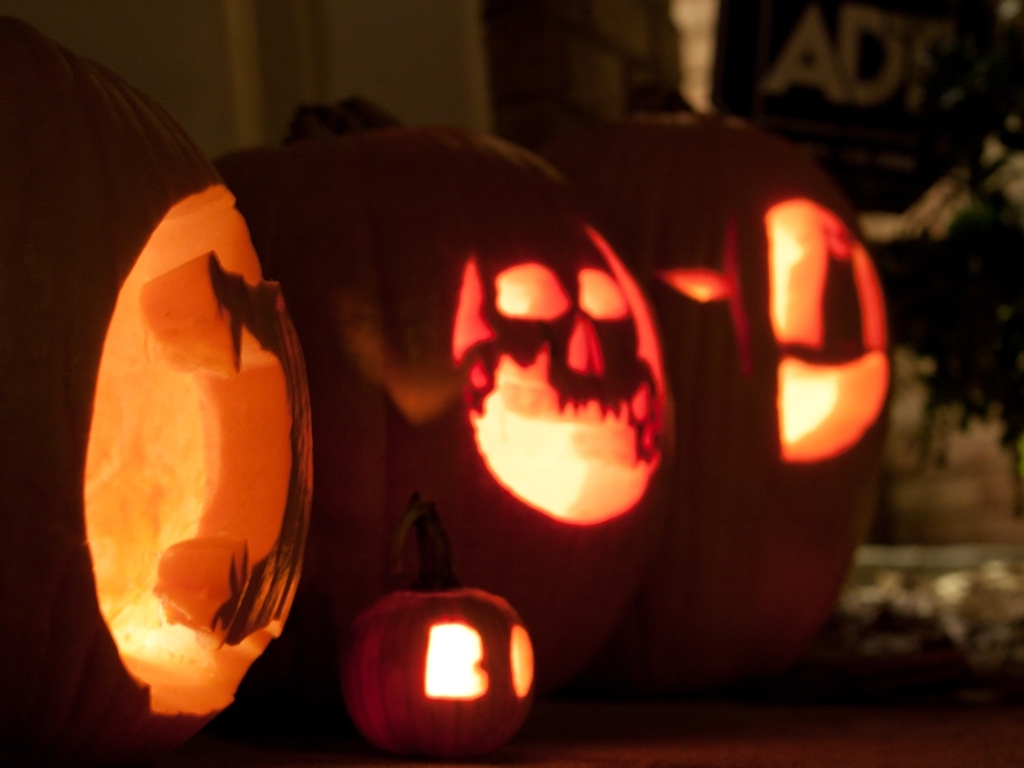Break down the quality aspects of the image and judge it from your analysis. This image effectively captures a thematic and festive atmosphere with its Halloween-themed pumpkin carvings. However, it experiences technical flaws: the photo is underexposed leading to a loss of detail, particularly in shadowed areas, and the focus is slightly blurred, which obscures finer texture details of the pumpkin surfaces. Despite these issues, the contrast created by the lit interiors of the pumpkins against the darker background adds a dramatic effect, suitable for the subject matter. 